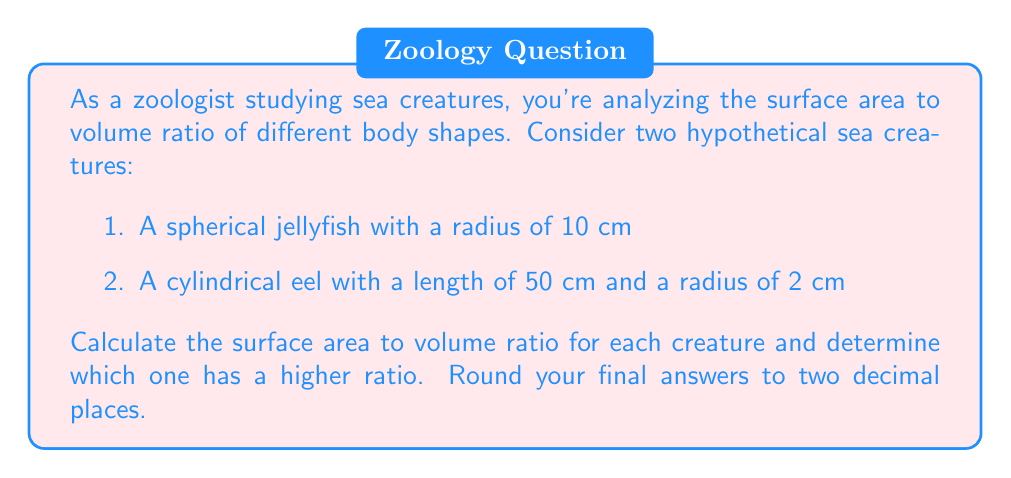What is the answer to this math problem? Let's approach this step-by-step:

1. For the spherical jellyfish:
   
   Surface Area: $$ SA_{sphere} = 4\pi r^2 $$
   $$ SA_{jellyfish} = 4\pi (10\text{ cm})^2 = 400\pi \text{ cm}^2 $$
   
   Volume: $$ V_{sphere} = \frac{4}{3}\pi r^3 $$
   $$ V_{jellyfish} = \frac{4}{3}\pi (10\text{ cm})^3 = \frac{4000\pi}{3} \text{ cm}^3 $$
   
   Surface Area to Volume Ratio:
   $$ \frac{SA_{jellyfish}}{V_{jellyfish}} = \frac{400\pi \text{ cm}^2}{\frac{4000\pi}{3} \text{ cm}^3} = \frac{3}{10\text{ cm}} = 0.3 \text{ cm}^{-1} $$

2. For the cylindrical eel:
   
   Surface Area: $$ SA_{cylinder} = 2\pi r^2 + 2\pi rh $$
   $$ SA_{eel} = 2\pi (2\text{ cm})^2 + 2\pi (2\text{ cm})(50\text{ cm}) = 8\pi \text{ cm}^2 + 200\pi \text{ cm}^2 = 208\pi \text{ cm}^2 $$
   
   Volume: $$ V_{cylinder} = \pi r^2 h $$
   $$ V_{eel} = \pi (2\text{ cm})^2 (50\text{ cm}) = 200\pi \text{ cm}^3 $$
   
   Surface Area to Volume Ratio:
   $$ \frac{SA_{eel}}{V_{eel}} = \frac{208\pi \text{ cm}^2}{200\pi \text{ cm}^3} = \frac{1.04}{\text{cm}} = 1.04 \text{ cm}^{-1} $$

Comparing the ratios:
Jellyfish: 0.30 cm^(-1)
Eel: 1.04 cm^(-1)

The eel has a higher surface area to volume ratio.
Answer: The surface area to volume ratios are:
Jellyfish: 0.30 cm^(-1)
Eel: 1.04 cm^(-1)

The cylindrical eel has a higher surface area to volume ratio. 